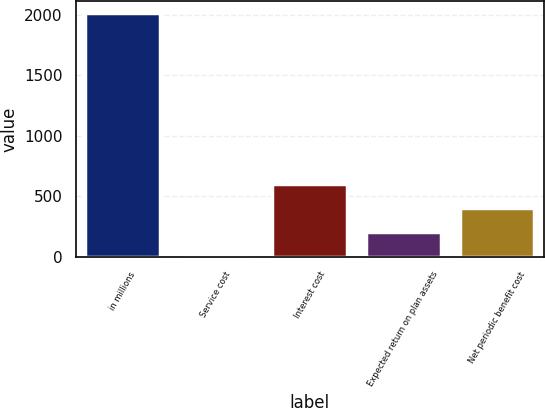Convert chart to OTSL. <chart><loc_0><loc_0><loc_500><loc_500><bar_chart><fcel>in millions<fcel>Service cost<fcel>Interest cost<fcel>Expected return on plan assets<fcel>Net periodic benefit cost<nl><fcel>2011<fcel>0.5<fcel>603.65<fcel>201.55<fcel>402.6<nl></chart> 